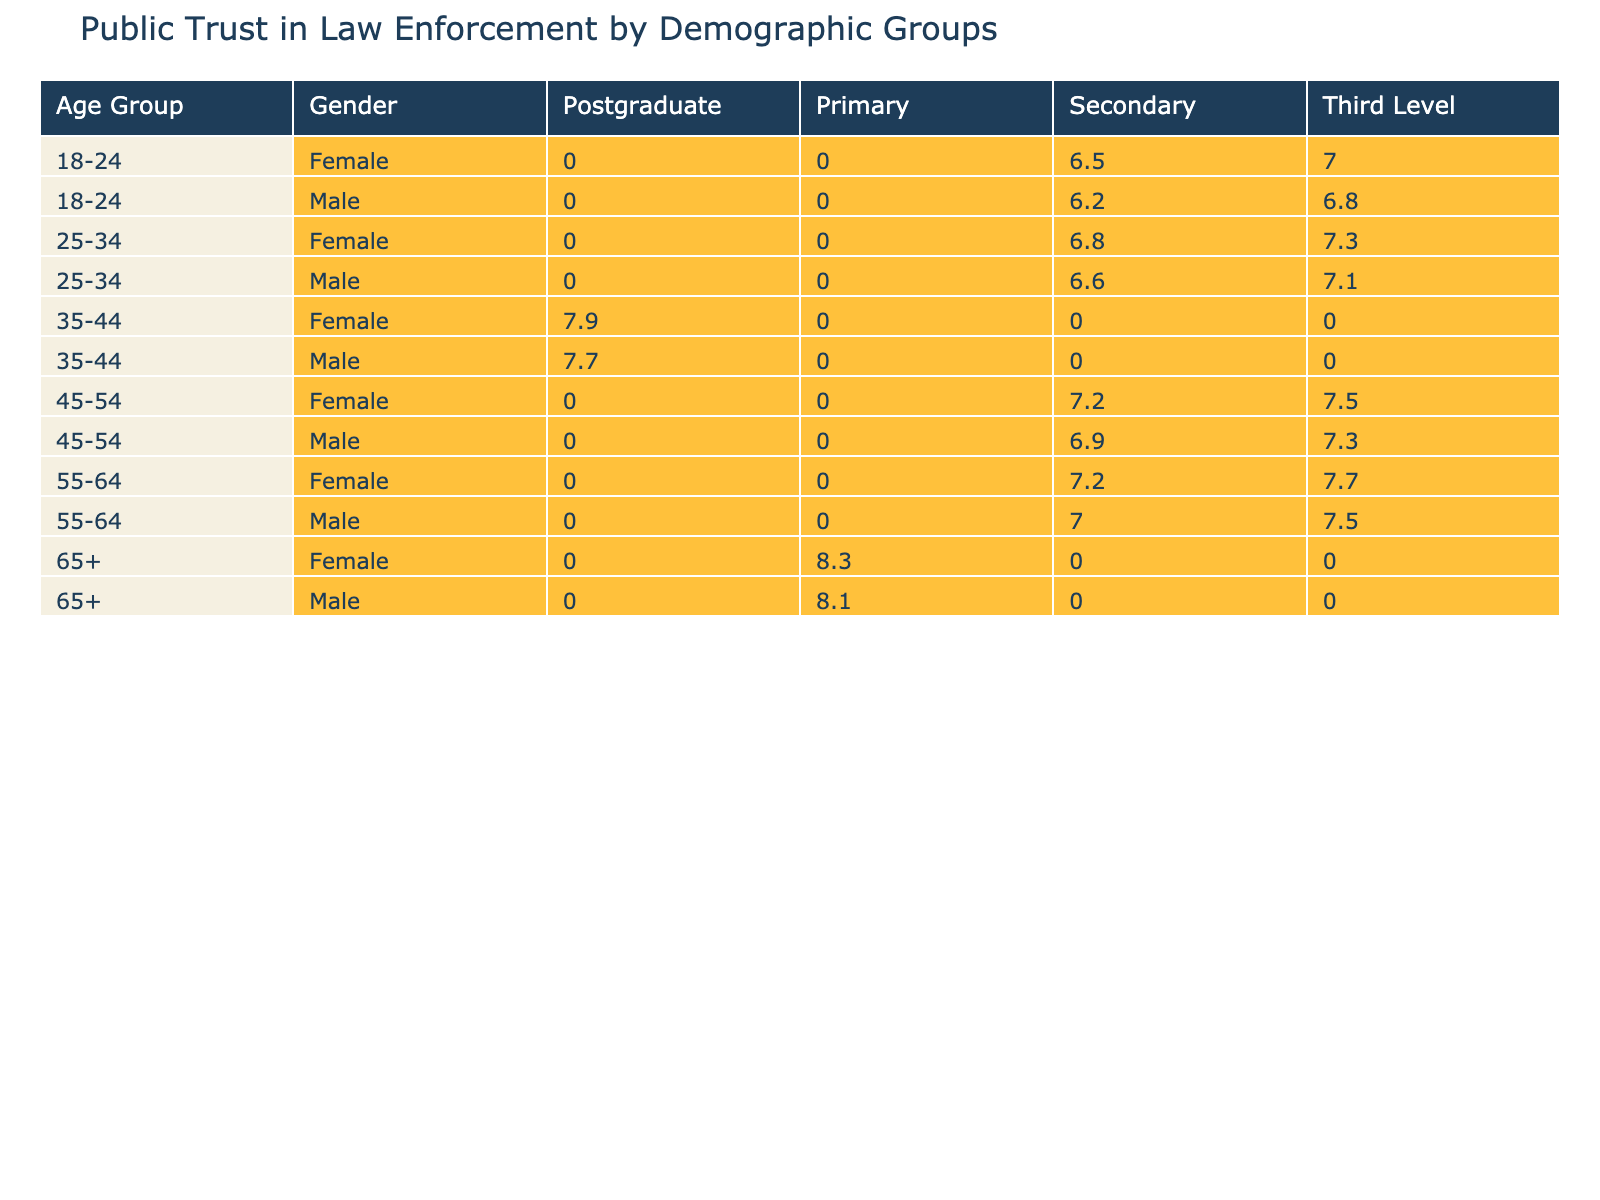What is the trust level of 18-24-year-old females in Dublin with a Secondary education? According to the table, for the demographic group of 18-24-year-old females in Dublin with a Secondary education, the trust level is reported as 6.5.
Answer: 6.5 Which age group has the highest average trust level across all education levels? To determine the age group with the highest average trust level, I observe the values for each age group. The averages are: 18-24 (6.6), 25-34 (7.2), 35-44 (7.9), 45-54 (7.4), 55-64 (7.3), and 65+ (8.3). The highest average is 8.3 for the 65+ age group.
Answer: 65+ Is there a noticeable gender difference in trust levels among 35-44-year-olds in Galway? For 35-44-year-olds in Galway, males have a trust level of 7.8, while females have a trust level of 8.0. Since 8.0 is higher than 7.8, there is a noticeable difference in favor of females.
Answer: Yes What is the difference in trust levels between males and females aged 55-64 in Waterford with Third Level education? For the demographic 55-64 in Waterford with Third Level education, males have a trust level of 7.5, and females have a trust level of 7.7. The difference is calculated by subtracting the male value from the female value: 7.7 - 7.5 = 0.2.
Answer: 0.2 Is the trust level of 18-24-year-old males in Donegal higher than that of 25-34-year-old females in Wexford? The trust level for 18-24-year-old males in Donegal is 6.8, while for 25-34-year-old females in Wexford, it is 6.8 as well. Since they are equal, the statement is false.
Answer: No What is the average trust level of all respondents from counties with Secondary education? To find the average trust level of respondents with Secondary education, I must add the trust levels of all such groups: Dublin (6.2 for males, 6.5 for females), Limerick (6.9 for males, 7.2 for females), Wexford (6.6 for males, 6.8 for females), and Kilkenny (7.0 for males, 7.2 for females). The total is 6.2 + 6.5 + 6.9 + 7.2 + 6.6 + 6.8 + 7.0 + 7.2 = 54.4, and now I divide by the number of respondents (8) to get the average: 54.4 / 8 = 6.8.
Answer: 6.8 Are there any 45-54-year-old females with a trust level above 7.0? Reviewing the data, the trust levels for 45-54-year-old females are 7.2 from Limerick and 7.5 from Mayo. Both values exceed 7.0, confirming the presence of such individuals.
Answer: Yes Which demographic group has the lowest trust level in the table, and what is that level? By examining the table, the demographic group with the lowest trust level is 25-34-year-old males in Wexford, whose trust level is listed as 6.6.
Answer: 6.6 